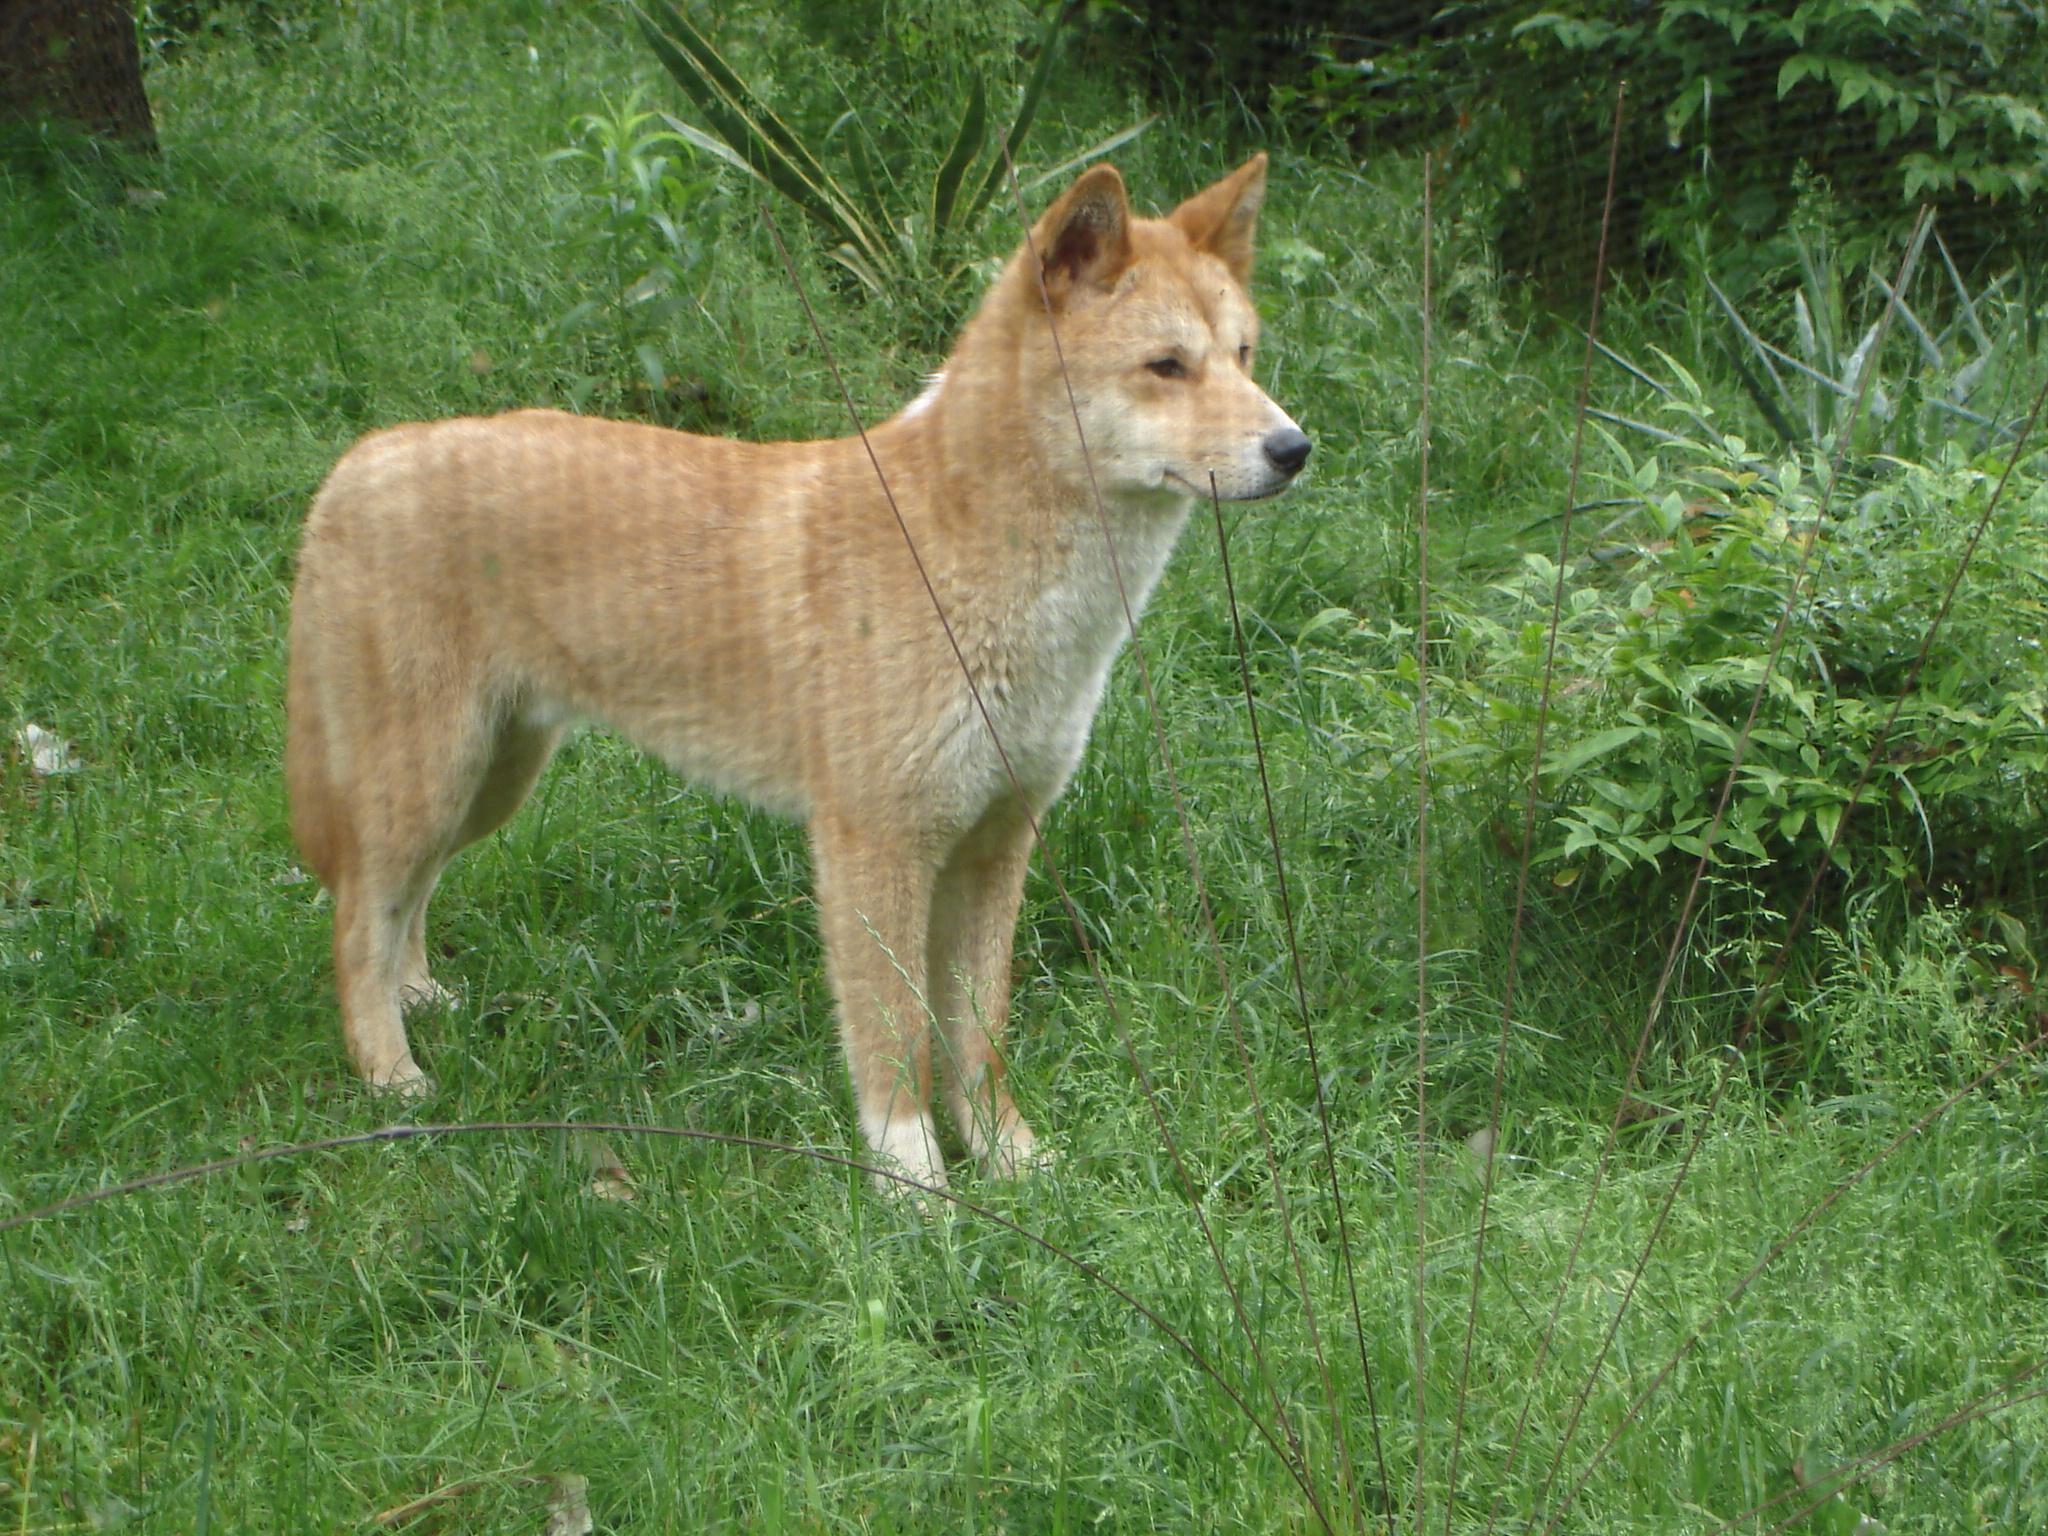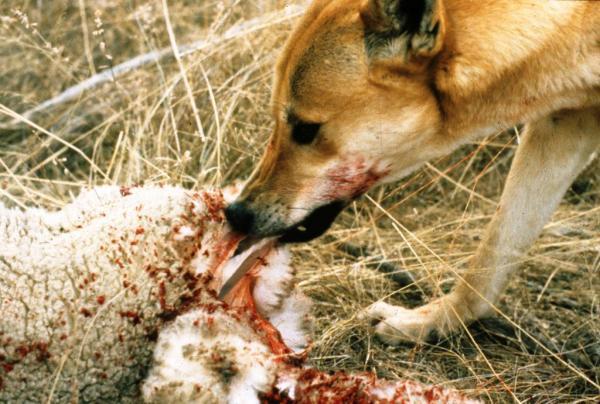The first image is the image on the left, the second image is the image on the right. For the images shown, is this caption "There is at least one dingo dog laying down." true? Answer yes or no. No. 